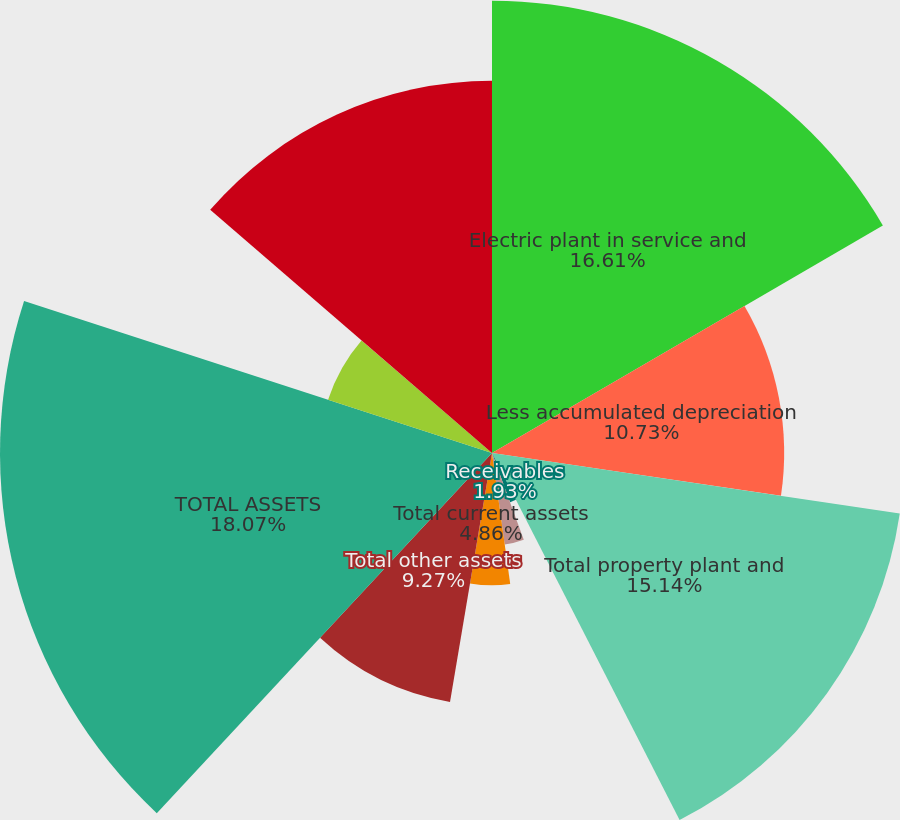<chart> <loc_0><loc_0><loc_500><loc_500><pie_chart><fcel>Electric plant in service and<fcel>Less accumulated depreciation<fcel>Total property plant and<fcel>Receivables<fcel>Other<fcel>Total current assets<fcel>Total other assets<fcel>TOTAL ASSETS<fcel>Common shareholders' equity<fcel>Total capitalization<nl><fcel>16.61%<fcel>10.73%<fcel>15.14%<fcel>1.93%<fcel>3.39%<fcel>4.86%<fcel>9.27%<fcel>18.07%<fcel>6.33%<fcel>13.67%<nl></chart> 